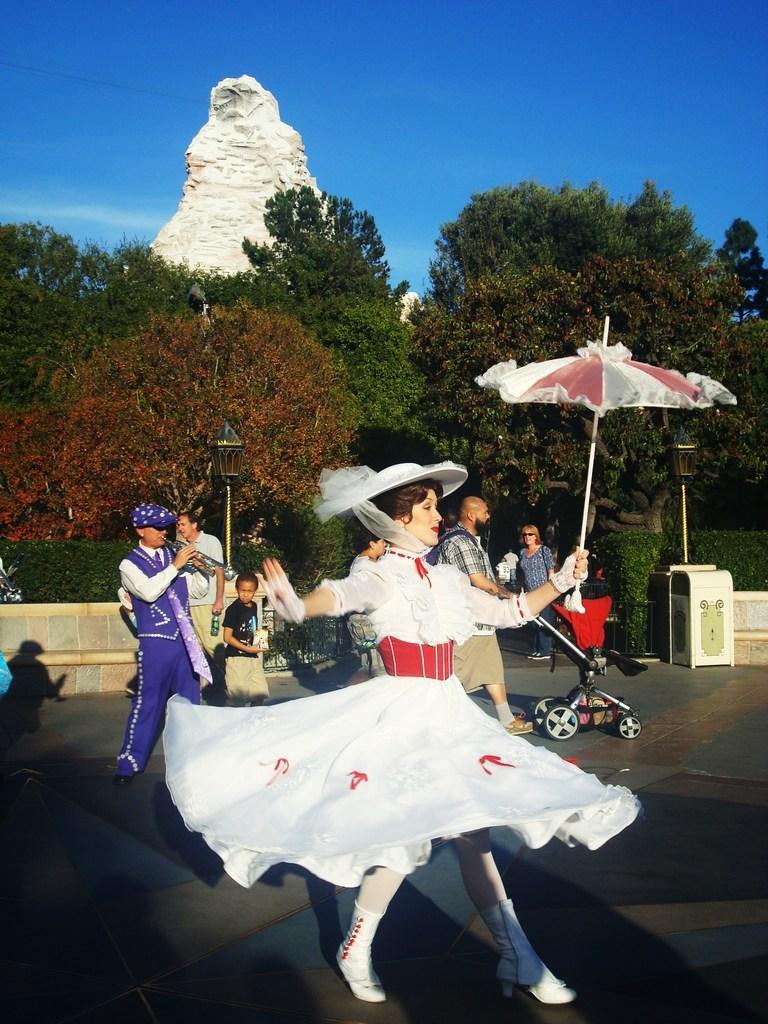Could you give a brief overview of what you see in this image? In this image on the road there are many people. In the foreground there is a lady wearing white frock and hat. She is holding an umbrella. Here there is a stroller. In the background there is bench, dustbin, trees and sky. 